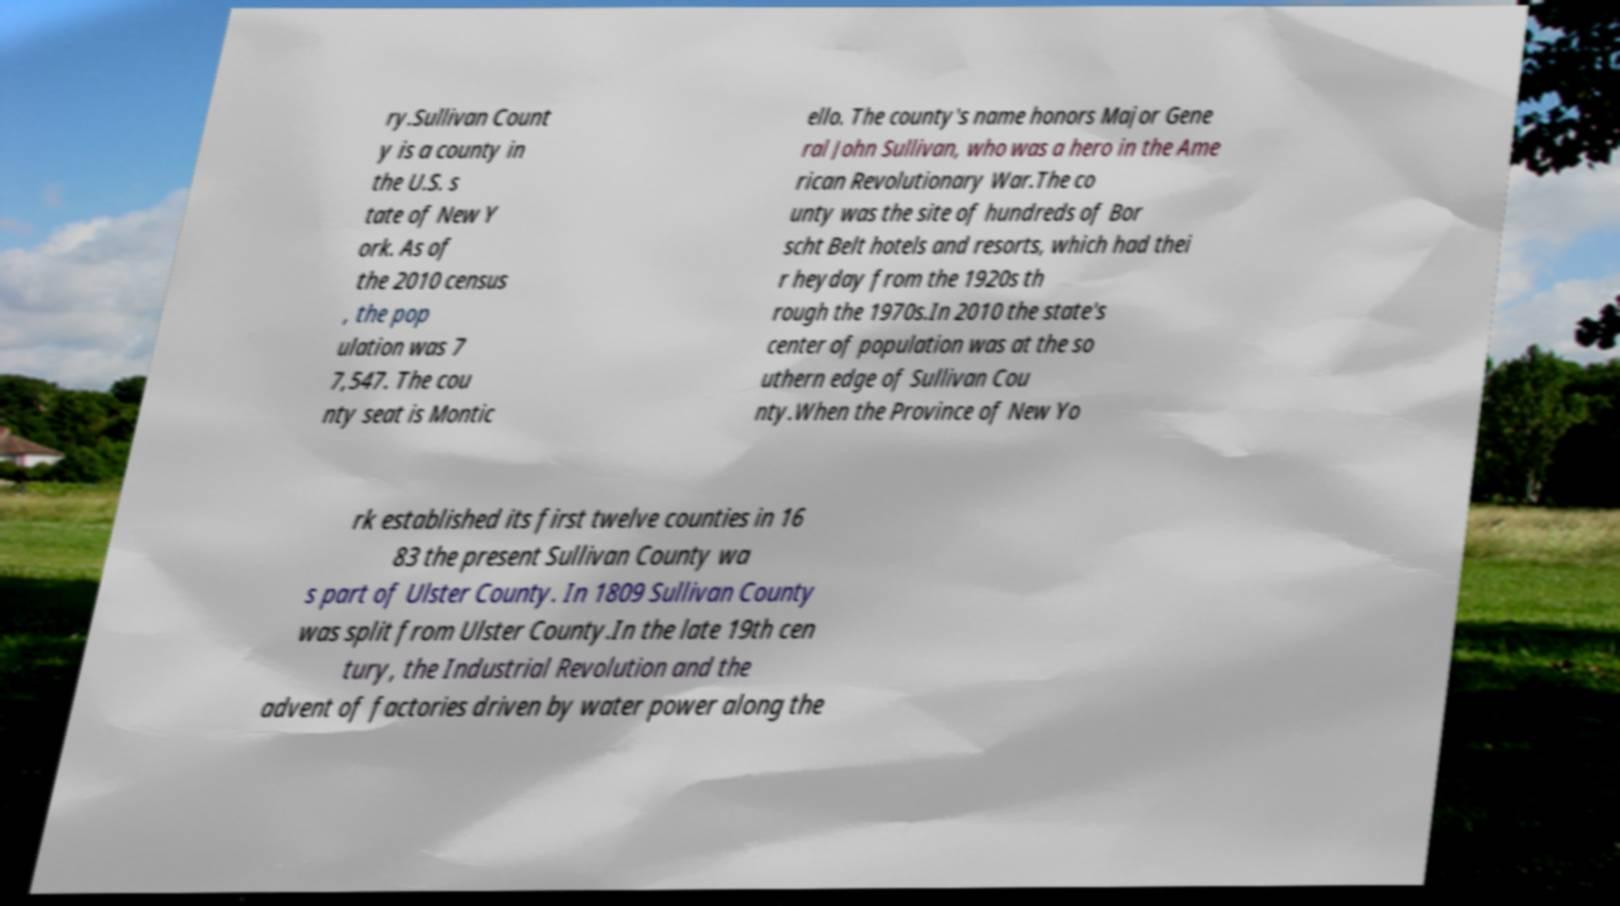Can you accurately transcribe the text from the provided image for me? ry.Sullivan Count y is a county in the U.S. s tate of New Y ork. As of the 2010 census , the pop ulation was 7 7,547. The cou nty seat is Montic ello. The county's name honors Major Gene ral John Sullivan, who was a hero in the Ame rican Revolutionary War.The co unty was the site of hundreds of Bor scht Belt hotels and resorts, which had thei r heyday from the 1920s th rough the 1970s.In 2010 the state's center of population was at the so uthern edge of Sullivan Cou nty.When the Province of New Yo rk established its first twelve counties in 16 83 the present Sullivan County wa s part of Ulster County. In 1809 Sullivan County was split from Ulster County.In the late 19th cen tury, the Industrial Revolution and the advent of factories driven by water power along the 